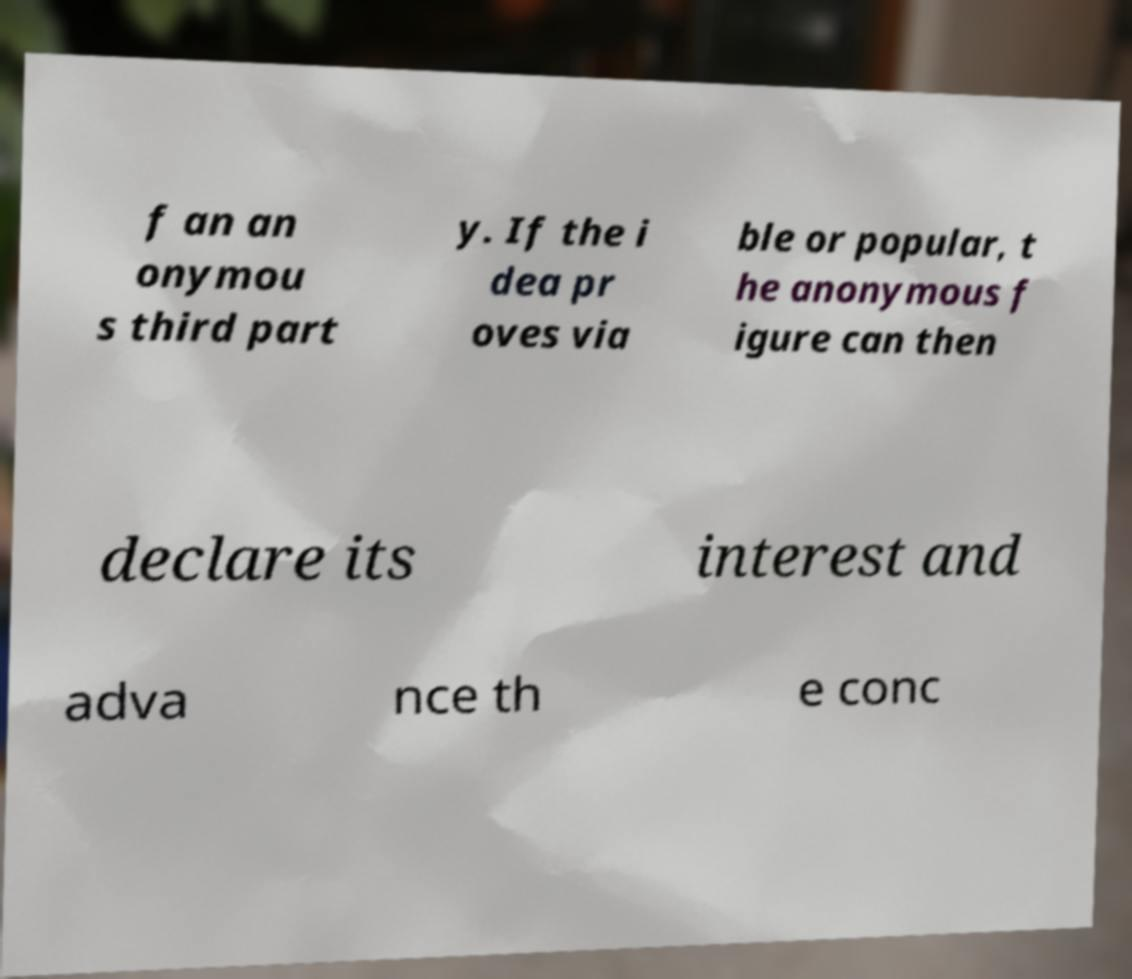Can you accurately transcribe the text from the provided image for me? f an an onymou s third part y. If the i dea pr oves via ble or popular, t he anonymous f igure can then declare its interest and adva nce th e conc 